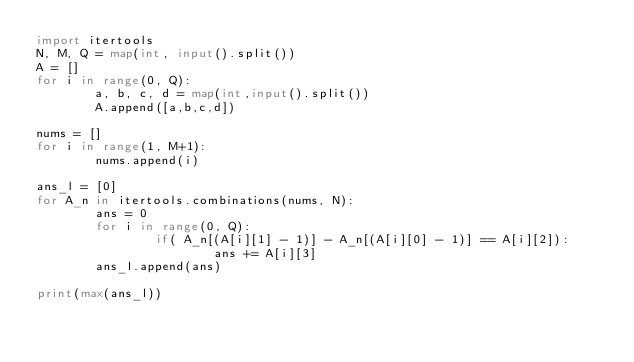<code> <loc_0><loc_0><loc_500><loc_500><_Python_>import itertools
N, M, Q = map(int, input().split())
A = []
for i in range(0, Q):
        a, b, c, d = map(int,input().split())
        A.append([a,b,c,d])

nums = []
for i in range(1, M+1):
        nums.append(i)

ans_l = [0]
for A_n in itertools.combinations(nums, N):
        ans = 0
        for i in range(0, Q):
                if( A_n[(A[i][1] - 1)] - A_n[(A[i][0] - 1)] == A[i][2]):
                        ans += A[i][3]
        ans_l.append(ans)

print(max(ans_l))</code> 